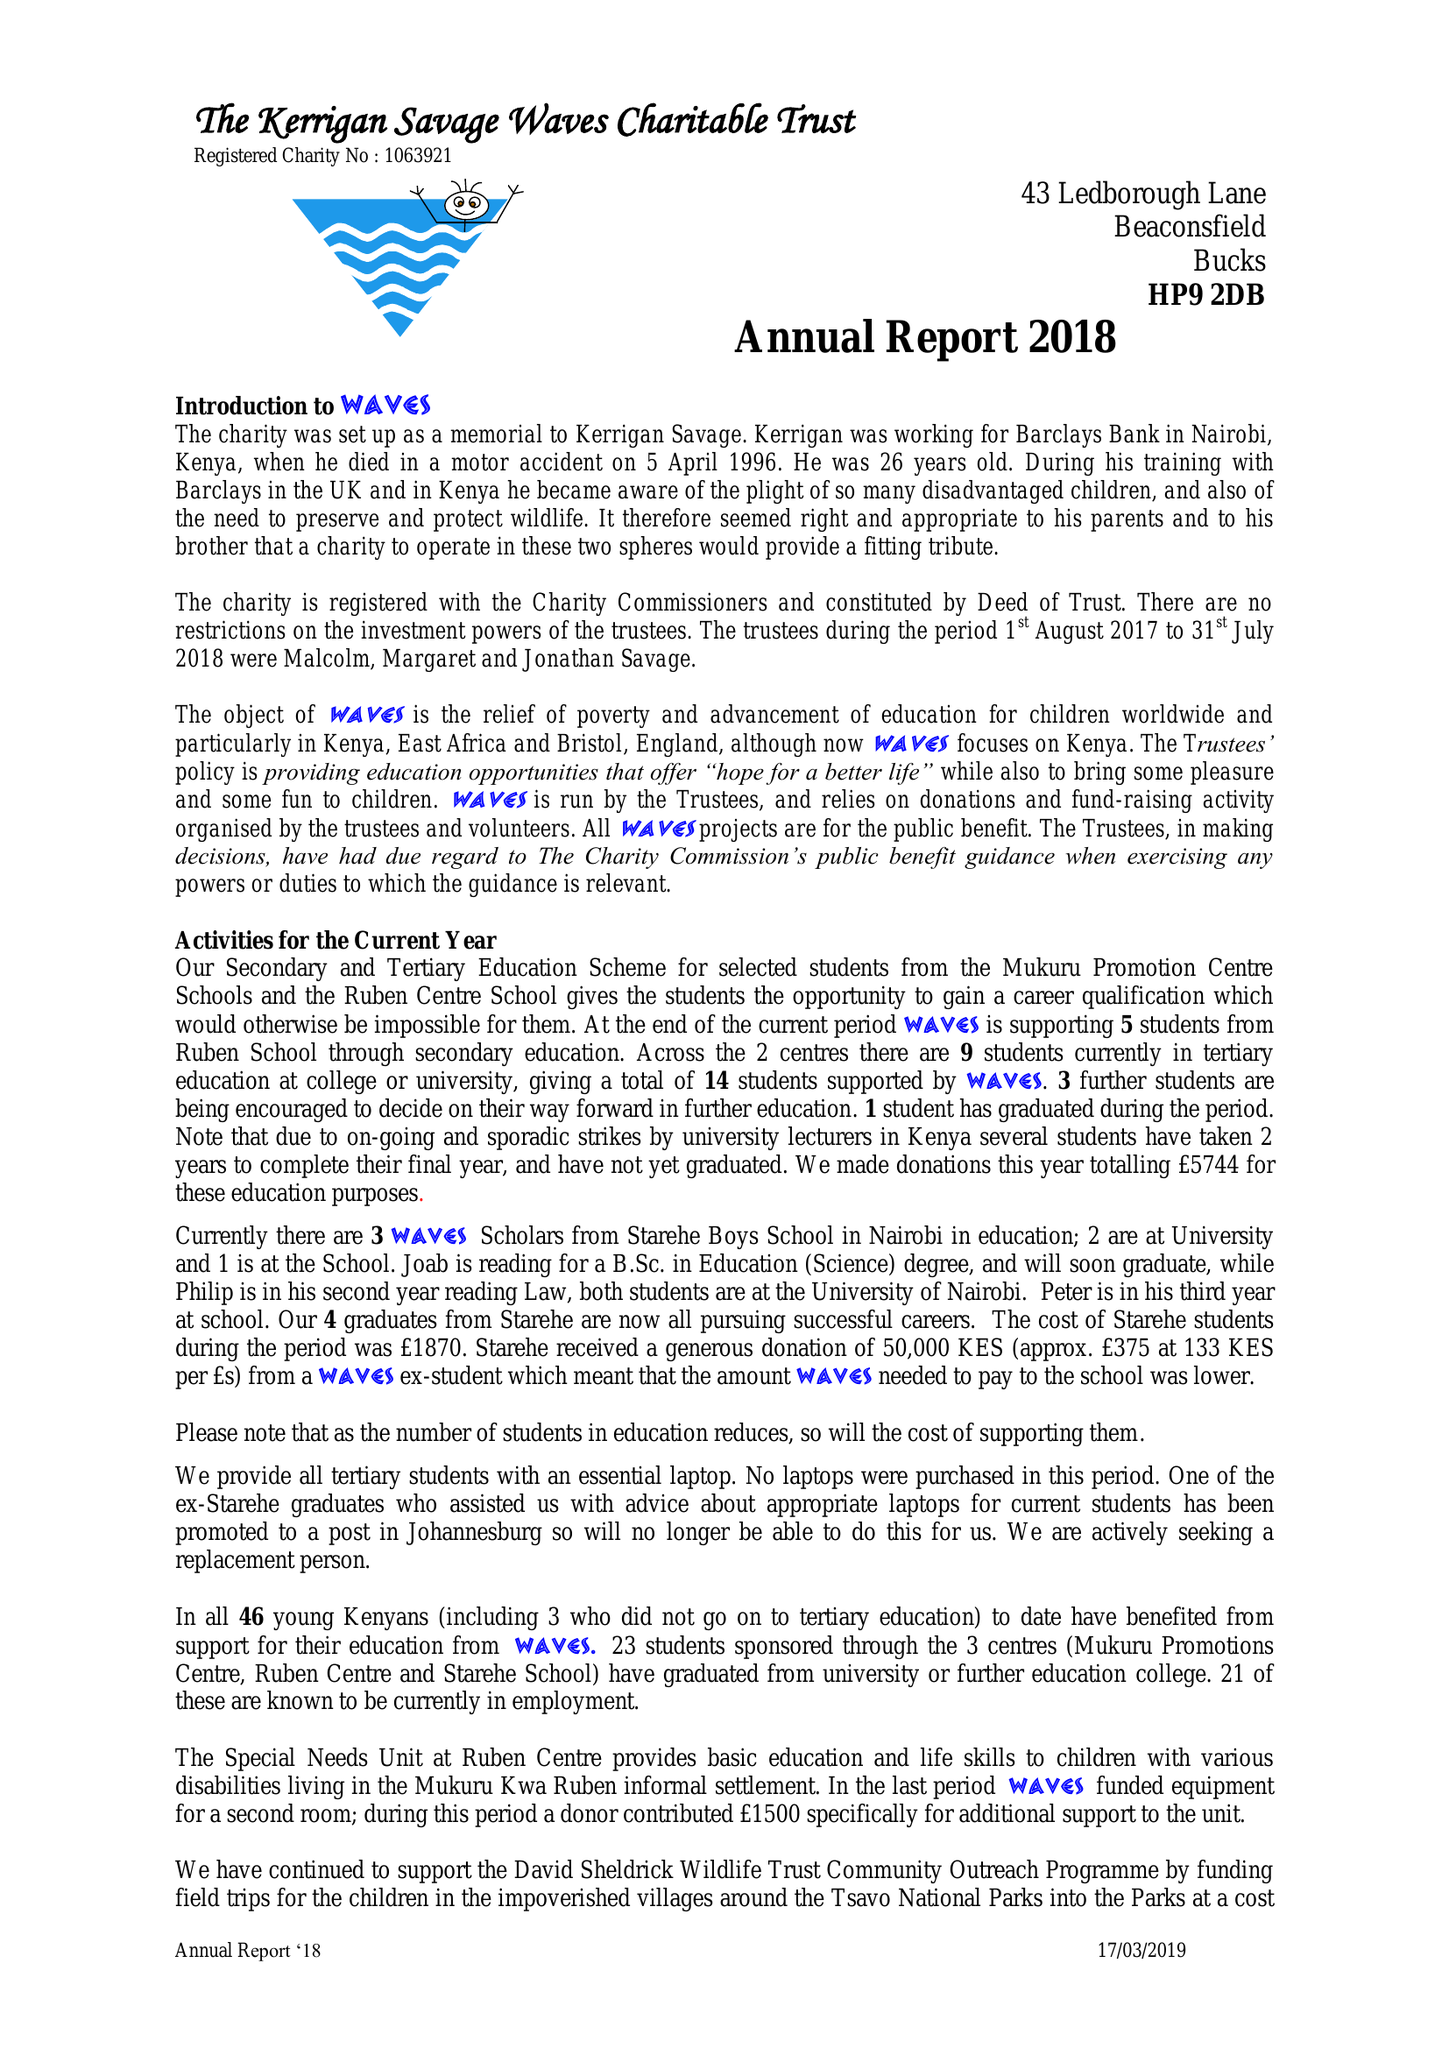What is the value for the charity_number?
Answer the question using a single word or phrase. 1063921 